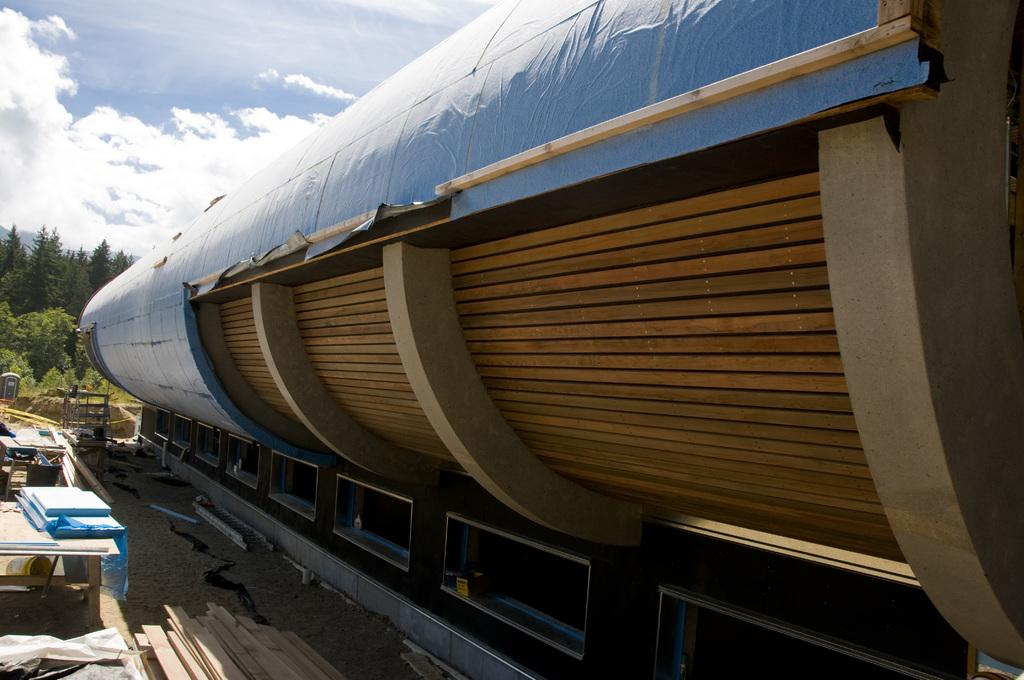What is happening in the image? There is construction activity in the image. What materials are being used in the construction? There are wooden sheets visible in the image. What type of natural elements can be seen in the image? There are trees and plants in the image. What is the condition of the sky in the image? The sky is visible in the image and it appears to be cloudy. What type of collar can be seen on the tree in the image? There is no collar present on the tree in the image; it is a natural element. 